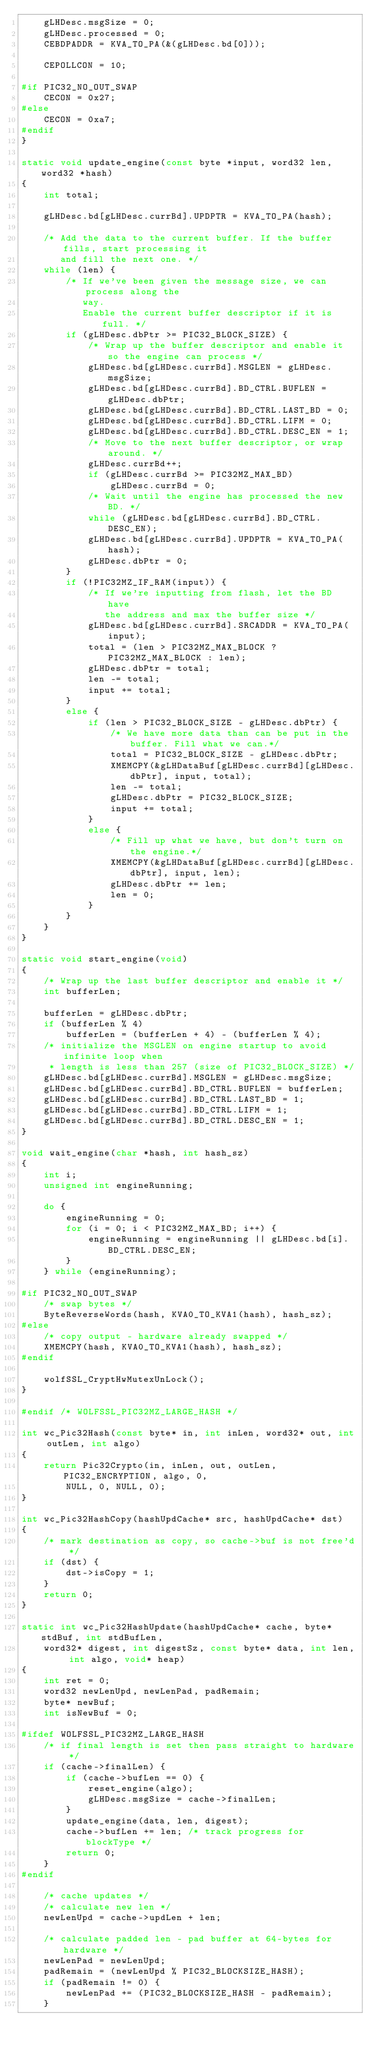Convert code to text. <code><loc_0><loc_0><loc_500><loc_500><_C_>    gLHDesc.msgSize = 0;
    gLHDesc.processed = 0;
    CEBDPADDR = KVA_TO_PA(&(gLHDesc.bd[0]));

    CEPOLLCON = 10;

#if PIC32_NO_OUT_SWAP
    CECON = 0x27;
#else
    CECON = 0xa7;
#endif
}

static void update_engine(const byte *input, word32 len, word32 *hash)
{
    int total;
    
    gLHDesc.bd[gLHDesc.currBd].UPDPTR = KVA_TO_PA(hash);

    /* Add the data to the current buffer. If the buffer fills, start processing it
       and fill the next one. */
    while (len) {
        /* If we've been given the message size, we can process along the
           way.
           Enable the current buffer descriptor if it is full. */
        if (gLHDesc.dbPtr >= PIC32_BLOCK_SIZE) {
            /* Wrap up the buffer descriptor and enable it so the engine can process */
            gLHDesc.bd[gLHDesc.currBd].MSGLEN = gLHDesc.msgSize;
            gLHDesc.bd[gLHDesc.currBd].BD_CTRL.BUFLEN = gLHDesc.dbPtr;
            gLHDesc.bd[gLHDesc.currBd].BD_CTRL.LAST_BD = 0;
            gLHDesc.bd[gLHDesc.currBd].BD_CTRL.LIFM = 0;
            gLHDesc.bd[gLHDesc.currBd].BD_CTRL.DESC_EN = 1;
            /* Move to the next buffer descriptor, or wrap around. */
            gLHDesc.currBd++;
            if (gLHDesc.currBd >= PIC32MZ_MAX_BD)
                gLHDesc.currBd = 0;
            /* Wait until the engine has processed the new BD. */
            while (gLHDesc.bd[gLHDesc.currBd].BD_CTRL.DESC_EN);
            gLHDesc.bd[gLHDesc.currBd].UPDPTR = KVA_TO_PA(hash);
            gLHDesc.dbPtr = 0;
        }
        if (!PIC32MZ_IF_RAM(input)) {
            /* If we're inputting from flash, let the BD have
               the address and max the buffer size */
            gLHDesc.bd[gLHDesc.currBd].SRCADDR = KVA_TO_PA(input);
            total = (len > PIC32MZ_MAX_BLOCK ? PIC32MZ_MAX_BLOCK : len);
            gLHDesc.dbPtr = total;
            len -= total;
            input += total;
        }
        else {
            if (len > PIC32_BLOCK_SIZE - gLHDesc.dbPtr) {
                /* We have more data than can be put in the buffer. Fill what we can.*/
                total = PIC32_BLOCK_SIZE - gLHDesc.dbPtr;
                XMEMCPY(&gLHDataBuf[gLHDesc.currBd][gLHDesc.dbPtr], input, total);
                len -= total;
                gLHDesc.dbPtr = PIC32_BLOCK_SIZE;
                input += total;
            }
            else {
                /* Fill up what we have, but don't turn on the engine.*/
                XMEMCPY(&gLHDataBuf[gLHDesc.currBd][gLHDesc.dbPtr], input, len);
                gLHDesc.dbPtr += len;
                len = 0;
            }
        }
    }
}

static void start_engine(void)
{
    /* Wrap up the last buffer descriptor and enable it */
    int bufferLen;

    bufferLen = gLHDesc.dbPtr;
    if (bufferLen % 4)
        bufferLen = (bufferLen + 4) - (bufferLen % 4);
    /* initialize the MSGLEN on engine startup to avoid infinite loop when
     * length is less than 257 (size of PIC32_BLOCK_SIZE) */
    gLHDesc.bd[gLHDesc.currBd].MSGLEN = gLHDesc.msgSize;
    gLHDesc.bd[gLHDesc.currBd].BD_CTRL.BUFLEN = bufferLen;
    gLHDesc.bd[gLHDesc.currBd].BD_CTRL.LAST_BD = 1;
    gLHDesc.bd[gLHDesc.currBd].BD_CTRL.LIFM = 1;
    gLHDesc.bd[gLHDesc.currBd].BD_CTRL.DESC_EN = 1;
}

void wait_engine(char *hash, int hash_sz)
{
    int i;
    unsigned int engineRunning;

    do {
        engineRunning = 0;
        for (i = 0; i < PIC32MZ_MAX_BD; i++) {
            engineRunning = engineRunning || gLHDesc.bd[i].BD_CTRL.DESC_EN;
        }
    } while (engineRunning);

#if PIC32_NO_OUT_SWAP
    /* swap bytes */
    ByteReverseWords(hash, KVA0_TO_KVA1(hash), hash_sz);
#else
    /* copy output - hardware already swapped */
    XMEMCPY(hash, KVA0_TO_KVA1(hash), hash_sz);
#endif

    wolfSSL_CryptHwMutexUnLock();
}

#endif /* WOLFSSL_PIC32MZ_LARGE_HASH */

int wc_Pic32Hash(const byte* in, int inLen, word32* out, int outLen, int algo)
{
    return Pic32Crypto(in, inLen, out, outLen, PIC32_ENCRYPTION, algo, 0,
        NULL, 0, NULL, 0);
}

int wc_Pic32HashCopy(hashUpdCache* src, hashUpdCache* dst)
{
    /* mark destination as copy, so cache->buf is not free'd */
    if (dst) {
        dst->isCopy = 1;
    }
    return 0;
}

static int wc_Pic32HashUpdate(hashUpdCache* cache, byte* stdBuf, int stdBufLen,
    word32* digest, int digestSz, const byte* data, int len, int algo, void* heap)
{
    int ret = 0;
    word32 newLenUpd, newLenPad, padRemain;
    byte* newBuf;
    int isNewBuf = 0;

#ifdef WOLFSSL_PIC32MZ_LARGE_HASH
    /* if final length is set then pass straight to hardware */
    if (cache->finalLen) {
        if (cache->bufLen == 0) {
            reset_engine(algo);
            gLHDesc.msgSize = cache->finalLen;
        }
        update_engine(data, len, digest);
        cache->bufLen += len; /* track progress for blockType */
        return 0;
    }
#endif

    /* cache updates */
    /* calculate new len */
    newLenUpd = cache->updLen + len;

    /* calculate padded len - pad buffer at 64-bytes for hardware */
    newLenPad = newLenUpd;
    padRemain = (newLenUpd % PIC32_BLOCKSIZE_HASH);
    if (padRemain != 0) {
        newLenPad += (PIC32_BLOCKSIZE_HASH - padRemain);
    }
</code> 